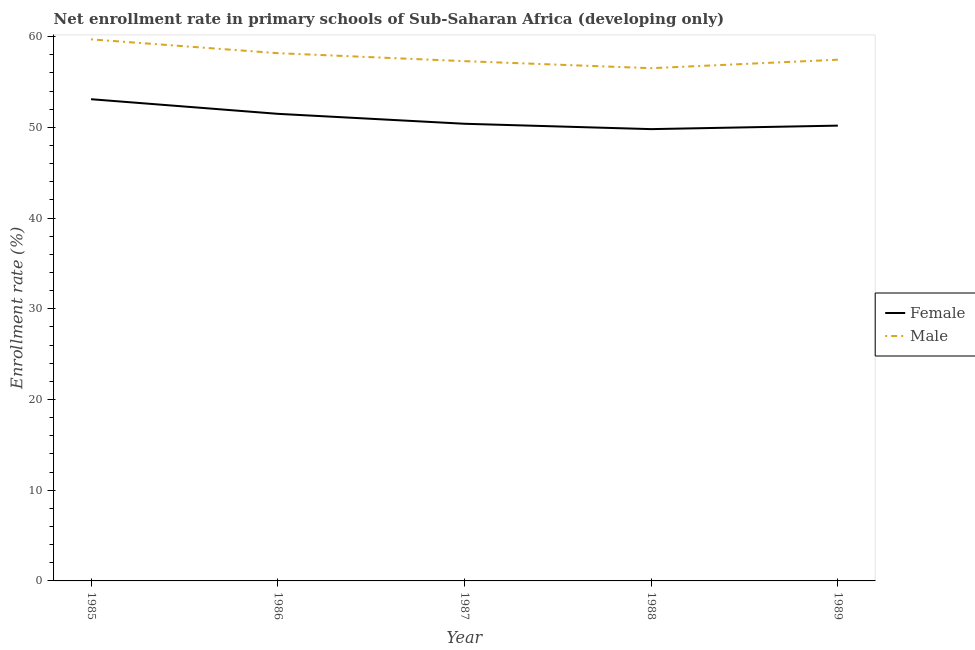Does the line corresponding to enrollment rate of female students intersect with the line corresponding to enrollment rate of male students?
Offer a terse response. No. What is the enrollment rate of female students in 1987?
Your response must be concise. 50.4. Across all years, what is the maximum enrollment rate of female students?
Provide a short and direct response. 53.11. Across all years, what is the minimum enrollment rate of male students?
Offer a very short reply. 56.53. In which year was the enrollment rate of male students maximum?
Offer a very short reply. 1985. In which year was the enrollment rate of male students minimum?
Provide a short and direct response. 1988. What is the total enrollment rate of female students in the graph?
Ensure brevity in your answer.  255. What is the difference between the enrollment rate of female students in 1985 and that in 1986?
Provide a succinct answer. 1.61. What is the difference between the enrollment rate of male students in 1987 and the enrollment rate of female students in 1985?
Keep it short and to the point. 4.2. What is the average enrollment rate of female students per year?
Your response must be concise. 51. In the year 1985, what is the difference between the enrollment rate of male students and enrollment rate of female students?
Offer a terse response. 6.6. What is the ratio of the enrollment rate of male students in 1985 to that in 1986?
Your response must be concise. 1.03. What is the difference between the highest and the second highest enrollment rate of male students?
Provide a succinct answer. 1.52. What is the difference between the highest and the lowest enrollment rate of female students?
Your response must be concise. 3.3. In how many years, is the enrollment rate of male students greater than the average enrollment rate of male students taken over all years?
Your response must be concise. 2. Is the sum of the enrollment rate of female students in 1985 and 1987 greater than the maximum enrollment rate of male students across all years?
Keep it short and to the point. Yes. Are the values on the major ticks of Y-axis written in scientific E-notation?
Provide a short and direct response. No. Where does the legend appear in the graph?
Your answer should be compact. Center right. How many legend labels are there?
Your answer should be very brief. 2. What is the title of the graph?
Your answer should be compact. Net enrollment rate in primary schools of Sub-Saharan Africa (developing only). Does "Diarrhea" appear as one of the legend labels in the graph?
Ensure brevity in your answer.  No. What is the label or title of the Y-axis?
Ensure brevity in your answer.  Enrollment rate (%). What is the Enrollment rate (%) of Female in 1985?
Provide a succinct answer. 53.11. What is the Enrollment rate (%) in Male in 1985?
Give a very brief answer. 59.7. What is the Enrollment rate (%) of Female in 1986?
Offer a terse response. 51.49. What is the Enrollment rate (%) in Male in 1986?
Keep it short and to the point. 58.18. What is the Enrollment rate (%) of Female in 1987?
Offer a terse response. 50.4. What is the Enrollment rate (%) of Male in 1987?
Give a very brief answer. 57.3. What is the Enrollment rate (%) of Female in 1988?
Offer a very short reply. 49.81. What is the Enrollment rate (%) of Male in 1988?
Offer a very short reply. 56.53. What is the Enrollment rate (%) in Female in 1989?
Ensure brevity in your answer.  50.19. What is the Enrollment rate (%) of Male in 1989?
Your answer should be very brief. 57.46. Across all years, what is the maximum Enrollment rate (%) in Female?
Your answer should be compact. 53.11. Across all years, what is the maximum Enrollment rate (%) in Male?
Provide a succinct answer. 59.7. Across all years, what is the minimum Enrollment rate (%) in Female?
Ensure brevity in your answer.  49.81. Across all years, what is the minimum Enrollment rate (%) of Male?
Offer a terse response. 56.53. What is the total Enrollment rate (%) of Female in the graph?
Give a very brief answer. 255. What is the total Enrollment rate (%) in Male in the graph?
Your response must be concise. 289.18. What is the difference between the Enrollment rate (%) of Female in 1985 and that in 1986?
Your answer should be very brief. 1.61. What is the difference between the Enrollment rate (%) of Male in 1985 and that in 1986?
Offer a terse response. 1.52. What is the difference between the Enrollment rate (%) of Female in 1985 and that in 1987?
Your answer should be compact. 2.71. What is the difference between the Enrollment rate (%) of Male in 1985 and that in 1987?
Provide a short and direct response. 2.4. What is the difference between the Enrollment rate (%) of Female in 1985 and that in 1988?
Provide a succinct answer. 3.3. What is the difference between the Enrollment rate (%) in Male in 1985 and that in 1988?
Make the answer very short. 3.18. What is the difference between the Enrollment rate (%) in Female in 1985 and that in 1989?
Ensure brevity in your answer.  2.91. What is the difference between the Enrollment rate (%) of Male in 1985 and that in 1989?
Make the answer very short. 2.24. What is the difference between the Enrollment rate (%) in Female in 1986 and that in 1987?
Offer a very short reply. 1.1. What is the difference between the Enrollment rate (%) in Male in 1986 and that in 1987?
Provide a short and direct response. 0.88. What is the difference between the Enrollment rate (%) in Female in 1986 and that in 1988?
Offer a very short reply. 1.69. What is the difference between the Enrollment rate (%) of Male in 1986 and that in 1988?
Offer a very short reply. 1.66. What is the difference between the Enrollment rate (%) in Female in 1986 and that in 1989?
Provide a succinct answer. 1.3. What is the difference between the Enrollment rate (%) in Male in 1986 and that in 1989?
Your response must be concise. 0.72. What is the difference between the Enrollment rate (%) in Female in 1987 and that in 1988?
Provide a short and direct response. 0.59. What is the difference between the Enrollment rate (%) in Male in 1987 and that in 1988?
Provide a short and direct response. 0.78. What is the difference between the Enrollment rate (%) of Female in 1987 and that in 1989?
Keep it short and to the point. 0.2. What is the difference between the Enrollment rate (%) in Male in 1987 and that in 1989?
Your answer should be compact. -0.16. What is the difference between the Enrollment rate (%) in Female in 1988 and that in 1989?
Your response must be concise. -0.39. What is the difference between the Enrollment rate (%) of Male in 1988 and that in 1989?
Provide a succinct answer. -0.94. What is the difference between the Enrollment rate (%) in Female in 1985 and the Enrollment rate (%) in Male in 1986?
Offer a very short reply. -5.08. What is the difference between the Enrollment rate (%) in Female in 1985 and the Enrollment rate (%) in Male in 1987?
Ensure brevity in your answer.  -4.2. What is the difference between the Enrollment rate (%) of Female in 1985 and the Enrollment rate (%) of Male in 1988?
Your response must be concise. -3.42. What is the difference between the Enrollment rate (%) in Female in 1985 and the Enrollment rate (%) in Male in 1989?
Offer a terse response. -4.36. What is the difference between the Enrollment rate (%) in Female in 1986 and the Enrollment rate (%) in Male in 1987?
Your response must be concise. -5.81. What is the difference between the Enrollment rate (%) of Female in 1986 and the Enrollment rate (%) of Male in 1988?
Offer a terse response. -5.03. What is the difference between the Enrollment rate (%) in Female in 1986 and the Enrollment rate (%) in Male in 1989?
Your answer should be very brief. -5.97. What is the difference between the Enrollment rate (%) of Female in 1987 and the Enrollment rate (%) of Male in 1988?
Your response must be concise. -6.13. What is the difference between the Enrollment rate (%) in Female in 1987 and the Enrollment rate (%) in Male in 1989?
Give a very brief answer. -7.06. What is the difference between the Enrollment rate (%) in Female in 1988 and the Enrollment rate (%) in Male in 1989?
Provide a succinct answer. -7.65. What is the average Enrollment rate (%) in Female per year?
Your answer should be compact. 51. What is the average Enrollment rate (%) in Male per year?
Provide a succinct answer. 57.84. In the year 1985, what is the difference between the Enrollment rate (%) of Female and Enrollment rate (%) of Male?
Give a very brief answer. -6.6. In the year 1986, what is the difference between the Enrollment rate (%) of Female and Enrollment rate (%) of Male?
Make the answer very short. -6.69. In the year 1987, what is the difference between the Enrollment rate (%) in Female and Enrollment rate (%) in Male?
Your response must be concise. -6.9. In the year 1988, what is the difference between the Enrollment rate (%) in Female and Enrollment rate (%) in Male?
Ensure brevity in your answer.  -6.72. In the year 1989, what is the difference between the Enrollment rate (%) of Female and Enrollment rate (%) of Male?
Offer a very short reply. -7.27. What is the ratio of the Enrollment rate (%) in Female in 1985 to that in 1986?
Your answer should be compact. 1.03. What is the ratio of the Enrollment rate (%) of Male in 1985 to that in 1986?
Ensure brevity in your answer.  1.03. What is the ratio of the Enrollment rate (%) in Female in 1985 to that in 1987?
Keep it short and to the point. 1.05. What is the ratio of the Enrollment rate (%) of Male in 1985 to that in 1987?
Provide a succinct answer. 1.04. What is the ratio of the Enrollment rate (%) in Female in 1985 to that in 1988?
Ensure brevity in your answer.  1.07. What is the ratio of the Enrollment rate (%) of Male in 1985 to that in 1988?
Your answer should be compact. 1.06. What is the ratio of the Enrollment rate (%) of Female in 1985 to that in 1989?
Keep it short and to the point. 1.06. What is the ratio of the Enrollment rate (%) of Male in 1985 to that in 1989?
Offer a terse response. 1.04. What is the ratio of the Enrollment rate (%) of Female in 1986 to that in 1987?
Keep it short and to the point. 1.02. What is the ratio of the Enrollment rate (%) of Male in 1986 to that in 1987?
Keep it short and to the point. 1.02. What is the ratio of the Enrollment rate (%) in Female in 1986 to that in 1988?
Give a very brief answer. 1.03. What is the ratio of the Enrollment rate (%) of Male in 1986 to that in 1988?
Give a very brief answer. 1.03. What is the ratio of the Enrollment rate (%) of Female in 1986 to that in 1989?
Give a very brief answer. 1.03. What is the ratio of the Enrollment rate (%) of Male in 1986 to that in 1989?
Keep it short and to the point. 1.01. What is the ratio of the Enrollment rate (%) of Female in 1987 to that in 1988?
Keep it short and to the point. 1.01. What is the ratio of the Enrollment rate (%) in Male in 1987 to that in 1988?
Your answer should be very brief. 1.01. What is the ratio of the Enrollment rate (%) in Female in 1987 to that in 1989?
Keep it short and to the point. 1. What is the ratio of the Enrollment rate (%) of Male in 1987 to that in 1989?
Keep it short and to the point. 1. What is the ratio of the Enrollment rate (%) in Male in 1988 to that in 1989?
Keep it short and to the point. 0.98. What is the difference between the highest and the second highest Enrollment rate (%) of Female?
Your answer should be very brief. 1.61. What is the difference between the highest and the second highest Enrollment rate (%) in Male?
Offer a very short reply. 1.52. What is the difference between the highest and the lowest Enrollment rate (%) in Female?
Provide a short and direct response. 3.3. What is the difference between the highest and the lowest Enrollment rate (%) of Male?
Your response must be concise. 3.18. 